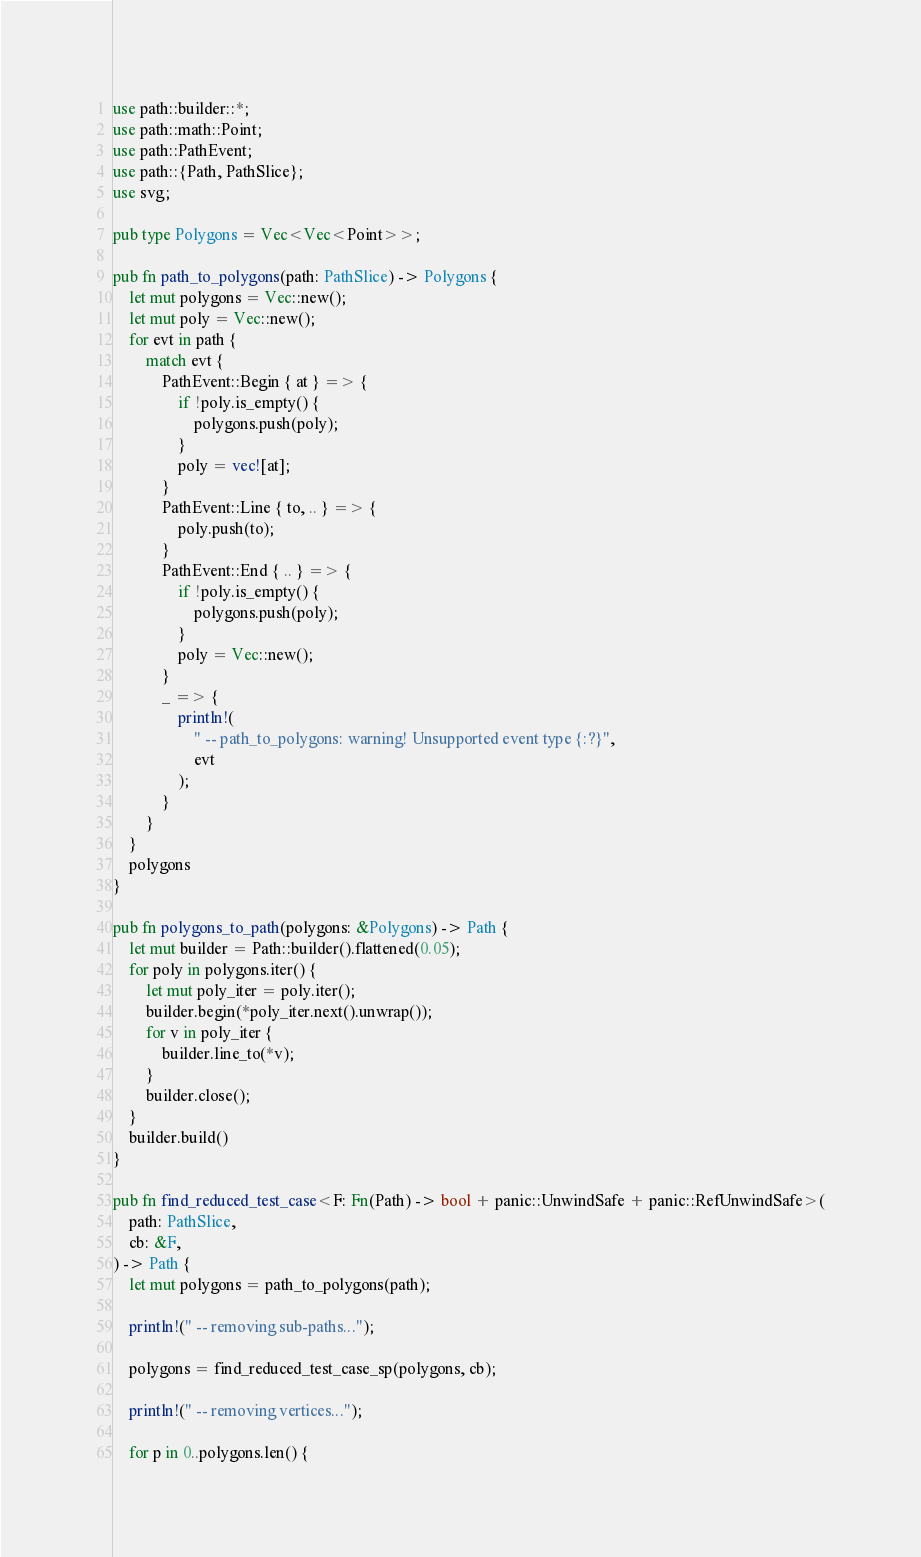<code> <loc_0><loc_0><loc_500><loc_500><_Rust_>use path::builder::*;
use path::math::Point;
use path::PathEvent;
use path::{Path, PathSlice};
use svg;

pub type Polygons = Vec<Vec<Point>>;

pub fn path_to_polygons(path: PathSlice) -> Polygons {
    let mut polygons = Vec::new();
    let mut poly = Vec::new();
    for evt in path {
        match evt {
            PathEvent::Begin { at } => {
                if !poly.is_empty() {
                    polygons.push(poly);
                }
                poly = vec![at];
            }
            PathEvent::Line { to, .. } => {
                poly.push(to);
            }
            PathEvent::End { .. } => {
                if !poly.is_empty() {
                    polygons.push(poly);
                }
                poly = Vec::new();
            }
            _ => {
                println!(
                    " -- path_to_polygons: warning! Unsupported event type {:?}",
                    evt
                );
            }
        }
    }
    polygons
}

pub fn polygons_to_path(polygons: &Polygons) -> Path {
    let mut builder = Path::builder().flattened(0.05);
    for poly in polygons.iter() {
        let mut poly_iter = poly.iter();
        builder.begin(*poly_iter.next().unwrap());
        for v in poly_iter {
            builder.line_to(*v);
        }
        builder.close();
    }
    builder.build()
}

pub fn find_reduced_test_case<F: Fn(Path) -> bool + panic::UnwindSafe + panic::RefUnwindSafe>(
    path: PathSlice,
    cb: &F,
) -> Path {
    let mut polygons = path_to_polygons(path);

    println!(" -- removing sub-paths...");

    polygons = find_reduced_test_case_sp(polygons, cb);

    println!(" -- removing vertices...");

    for p in 0..polygons.len() {</code> 